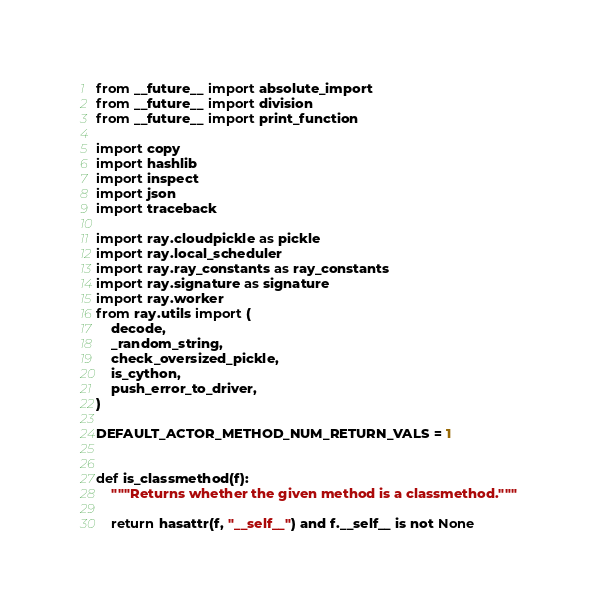<code> <loc_0><loc_0><loc_500><loc_500><_Python_>from __future__ import absolute_import
from __future__ import division
from __future__ import print_function

import copy
import hashlib
import inspect
import json
import traceback

import ray.cloudpickle as pickle
import ray.local_scheduler
import ray.ray_constants as ray_constants
import ray.signature as signature
import ray.worker
from ray.utils import (
    decode,
    _random_string,
    check_oversized_pickle,
    is_cython,
    push_error_to_driver,
)

DEFAULT_ACTOR_METHOD_NUM_RETURN_VALS = 1


def is_classmethod(f):
    """Returns whether the given method is a classmethod."""

    return hasattr(f, "__self__") and f.__self__ is not None

</code> 